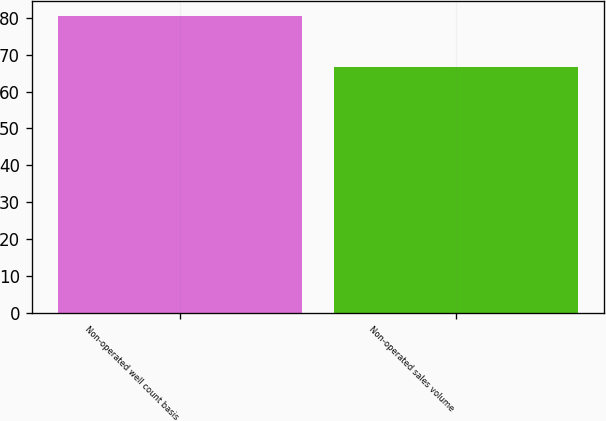<chart> <loc_0><loc_0><loc_500><loc_500><bar_chart><fcel>Non-operated well count basis<fcel>Non-operated sales volume<nl><fcel>80.4<fcel>66.7<nl></chart> 